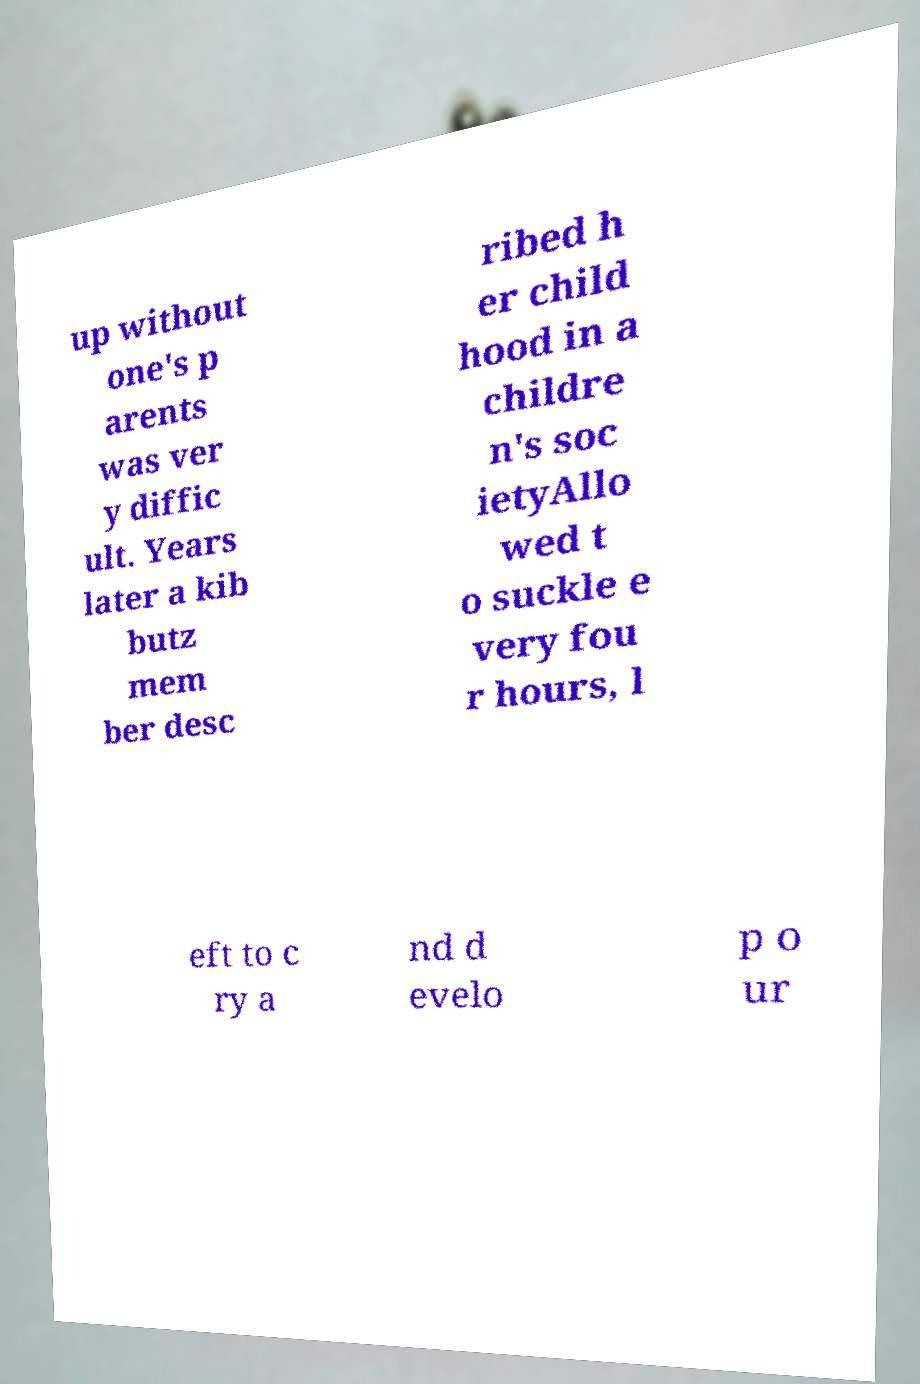For documentation purposes, I need the text within this image transcribed. Could you provide that? up without one's p arents was ver y diffic ult. Years later a kib butz mem ber desc ribed h er child hood in a childre n's soc ietyAllo wed t o suckle e very fou r hours, l eft to c ry a nd d evelo p o ur 